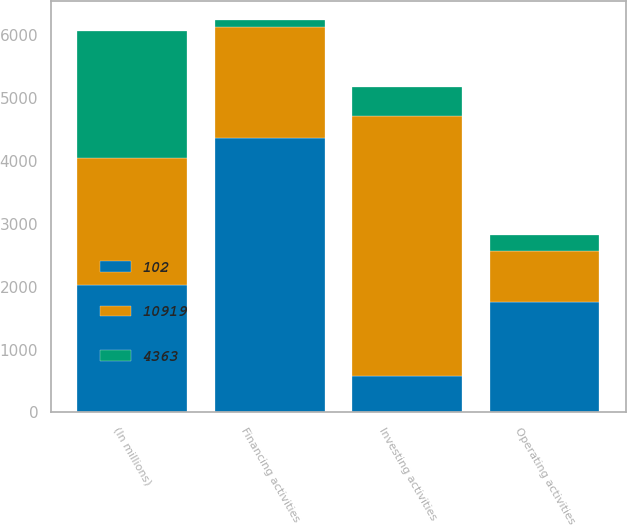Convert chart to OTSL. <chart><loc_0><loc_0><loc_500><loc_500><stacked_bar_chart><ecel><fcel>(In millions)<fcel>Operating activities<fcel>Investing activities<fcel>Financing activities<nl><fcel>102<fcel>2018<fcel>1762<fcel>578<fcel>4363<nl><fcel>10919<fcel>2017<fcel>799<fcel>4123<fcel>1762<nl><fcel>4363<fcel>2016<fcel>262<fcel>472<fcel>102<nl></chart> 